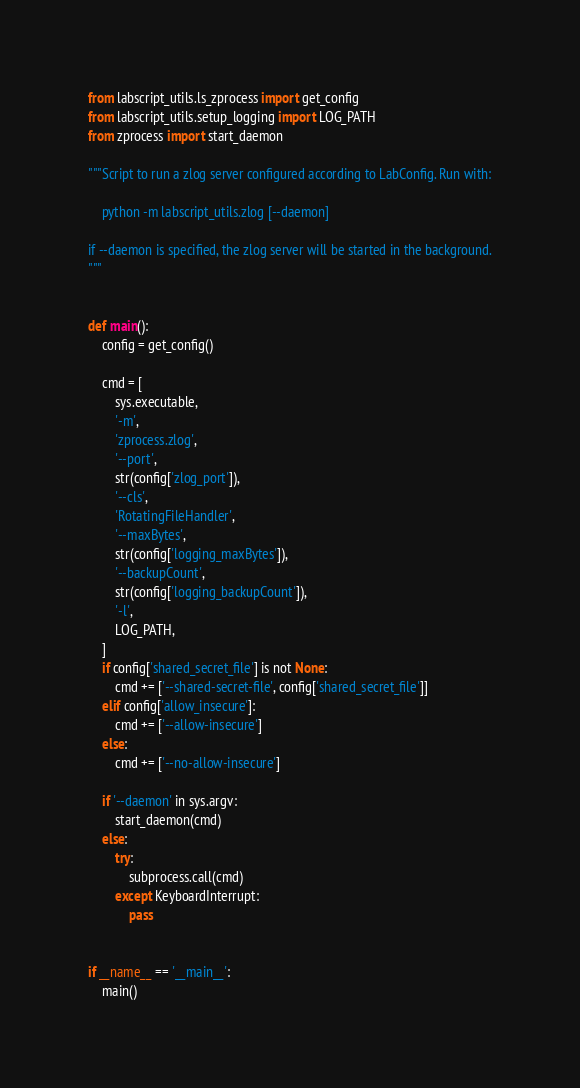<code> <loc_0><loc_0><loc_500><loc_500><_Python_>from labscript_utils.ls_zprocess import get_config
from labscript_utils.setup_logging import LOG_PATH
from zprocess import start_daemon

"""Script to run a zlog server configured according to LabConfig. Run with:

    python -m labscript_utils.zlog [--daemon]

if --daemon is specified, the zlog server will be started in the background.
"""


def main():
    config = get_config()

    cmd = [
        sys.executable,
        '-m',
        'zprocess.zlog',
        '--port',
        str(config['zlog_port']),
        '--cls',
        'RotatingFileHandler',
        '--maxBytes',
        str(config['logging_maxBytes']),
        '--backupCount',
        str(config['logging_backupCount']),
        '-l',
        LOG_PATH,
    ]
    if config['shared_secret_file'] is not None:
        cmd += ['--shared-secret-file', config['shared_secret_file']]
    elif config['allow_insecure']:
        cmd += ['--allow-insecure']
    else:
        cmd += ['--no-allow-insecure']

    if '--daemon' in sys.argv:
        start_daemon(cmd)
    else:
        try:
            subprocess.call(cmd)
        except KeyboardInterrupt:
            pass


if __name__ == '__main__':
    main()
</code> 